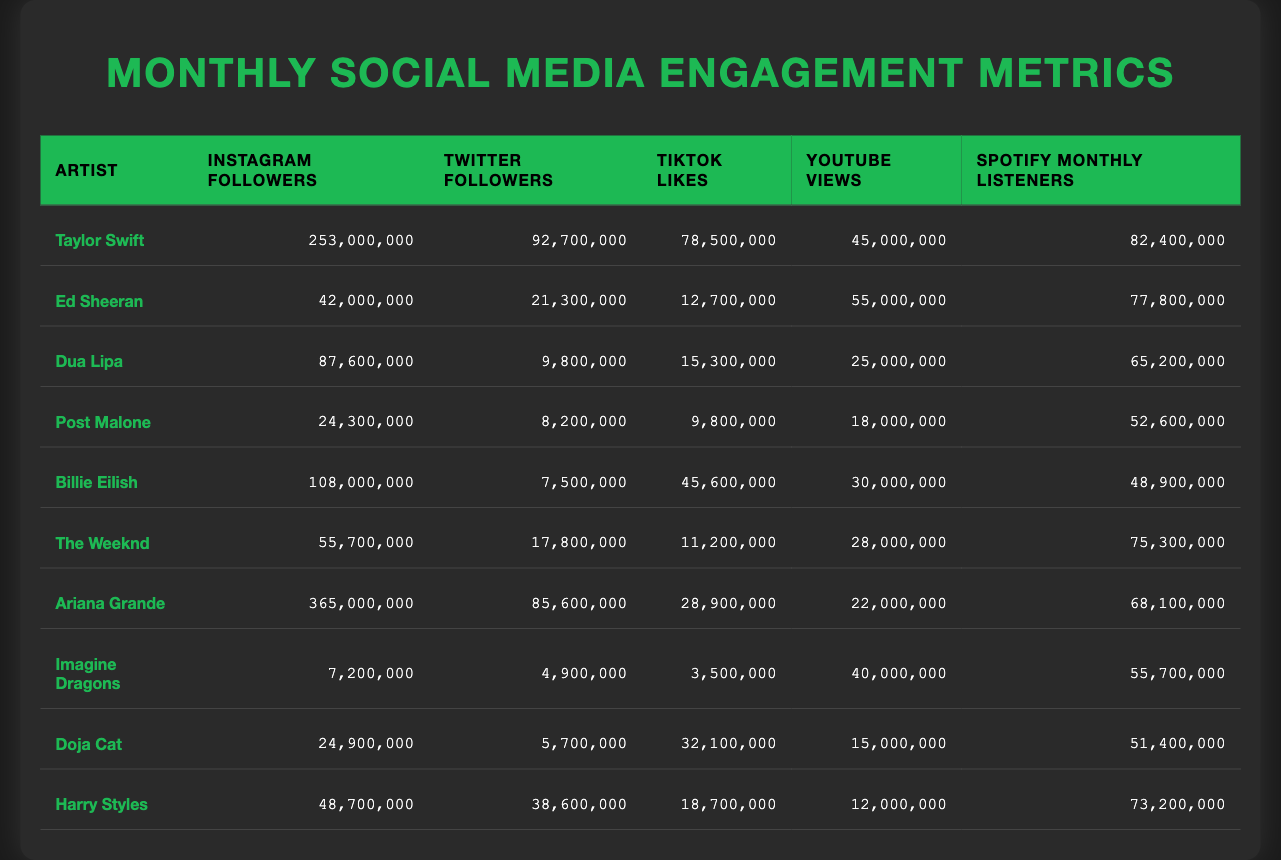What is the total number of Instagram followers for all artists listed? To find the total, we add the Instagram followers of each artist: 253000000 + 42000000 + 87600000 + 24300000 + 108000000 + 55700000 + 365000000 + 7200000 + 24900000 + 48700000 = 900000000.
Answer: 900000000 Which artist has the highest number of TikTok Likes? Looking at the TikTok Likes column, Taylor Swift has 78500000, which is the highest compared to other artists.
Answer: Taylor Swift True or False: Billie Eilish has more YouTube Views than Post Malone. Billie Eilish has 30000000 YouTube Views and Post Malone has 18000000. Since 30000000 is greater than 18000000, the statement is true.
Answer: True What is the average number of Spotify Monthly Listeners for all artists? First, add the Spotify Monthly Listeners: 82400000 + 77800000 + 65200000 + 52600000 + 48900000 + 75300000 + 68100000 + 55700000 + 51400000 + 73200000 =  686000000. Then, divide by the number of artists (10): 686000000 / 10 = 68600000.
Answer: 68600000 Which artist has the lowest number of Twitter Followers? Post Malone has 8200000 Twitter Followers, which is the lowest compared to all other artists' Twitter counts.
Answer: Post Malone What is the difference in YouTube Views between the artist with the highest and lowest counts? Billie Eilish has 30000000 YouTube Views (highest) and Imagine Dragons has 40000000 YouTube Views (lowest). Calculating the difference: 40000000 - 30000000 = 10000000.
Answer: 10000000 How many artists have more than 50000000 Spotify Monthly Listeners? Checking the Spotify Monthly Listeners column, the artists with more than 50000000 are Taylor Swift, Ed Sheeran, Dua Lipa, Billie Eilish, The Weeknd, Ariana Grande, and Harry Styles. This sums up to a total of 6 artists.
Answer: 6 True or False: Doja Cat has more Twitter Followers than Dua Lipa. Doja Cat has 5700000 Twitter Followers while Dua Lipa has 9800000. Since 5700000 is less than 9800000, the statement is false.
Answer: False What is the sum of TikTok Likes for artists with more than 70000000 TikTok Likes? The only artists with more than 70000000 TikTok Likes are Taylor Swift (78500000) and Billie Eilish (45600000). Adding these together: 78500000 + 45600000 = 124100000.
Answer: 124100000 